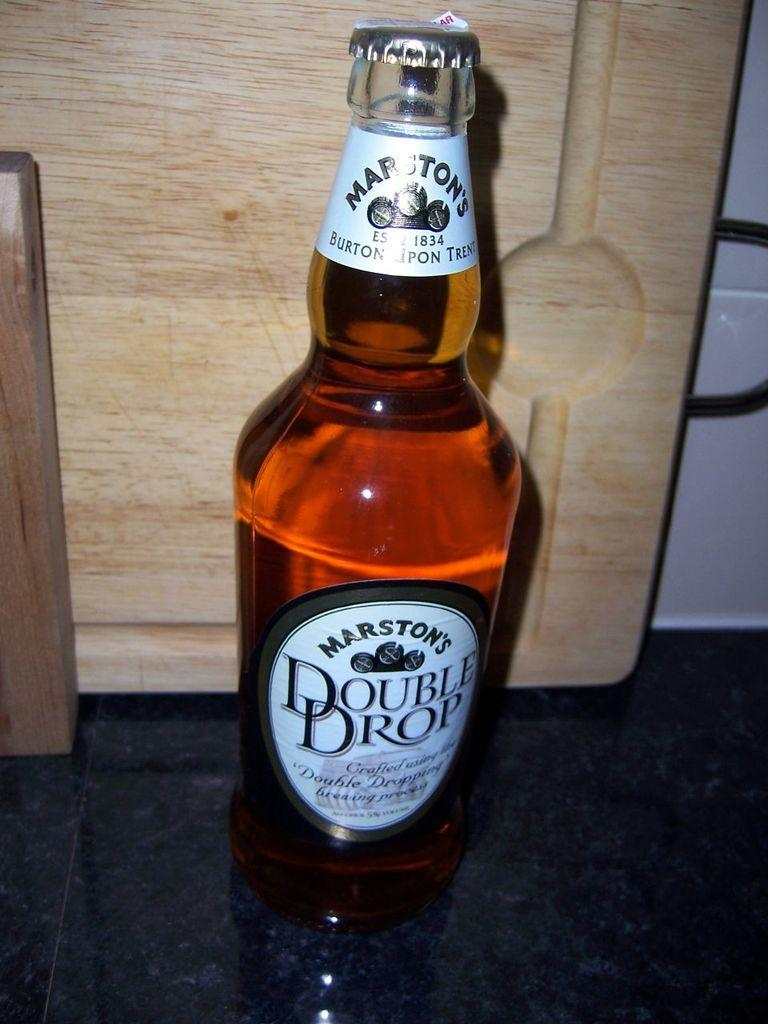<image>
Render a clear and concise summary of the photo. A bottle of Double Drop sits next to a wooden cutting board. 